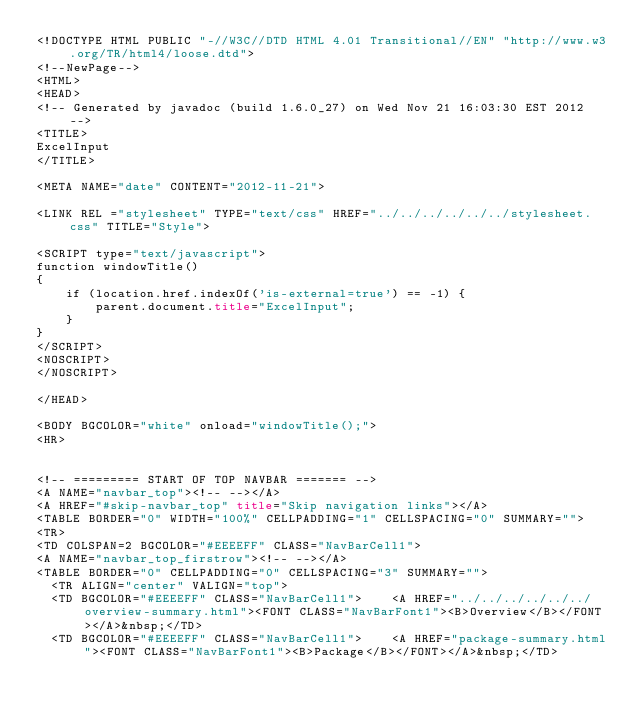Convert code to text. <code><loc_0><loc_0><loc_500><loc_500><_HTML_><!DOCTYPE HTML PUBLIC "-//W3C//DTD HTML 4.01 Transitional//EN" "http://www.w3.org/TR/html4/loose.dtd">
<!--NewPage-->
<HTML>
<HEAD>
<!-- Generated by javadoc (build 1.6.0_27) on Wed Nov 21 16:03:30 EST 2012 -->
<TITLE>
ExcelInput
</TITLE>

<META NAME="date" CONTENT="2012-11-21">

<LINK REL ="stylesheet" TYPE="text/css" HREF="../../../../../../stylesheet.css" TITLE="Style">

<SCRIPT type="text/javascript">
function windowTitle()
{
    if (location.href.indexOf('is-external=true') == -1) {
        parent.document.title="ExcelInput";
    }
}
</SCRIPT>
<NOSCRIPT>
</NOSCRIPT>

</HEAD>

<BODY BGCOLOR="white" onload="windowTitle();">
<HR>


<!-- ========= START OF TOP NAVBAR ======= -->
<A NAME="navbar_top"><!-- --></A>
<A HREF="#skip-navbar_top" title="Skip navigation links"></A>
<TABLE BORDER="0" WIDTH="100%" CELLPADDING="1" CELLSPACING="0" SUMMARY="">
<TR>
<TD COLSPAN=2 BGCOLOR="#EEEEFF" CLASS="NavBarCell1">
<A NAME="navbar_top_firstrow"><!-- --></A>
<TABLE BORDER="0" CELLPADDING="0" CELLSPACING="3" SUMMARY="">
  <TR ALIGN="center" VALIGN="top">
  <TD BGCOLOR="#EEEEFF" CLASS="NavBarCell1">    <A HREF="../../../../../../overview-summary.html"><FONT CLASS="NavBarFont1"><B>Overview</B></FONT></A>&nbsp;</TD>
  <TD BGCOLOR="#EEEEFF" CLASS="NavBarCell1">    <A HREF="package-summary.html"><FONT CLASS="NavBarFont1"><B>Package</B></FONT></A>&nbsp;</TD></code> 